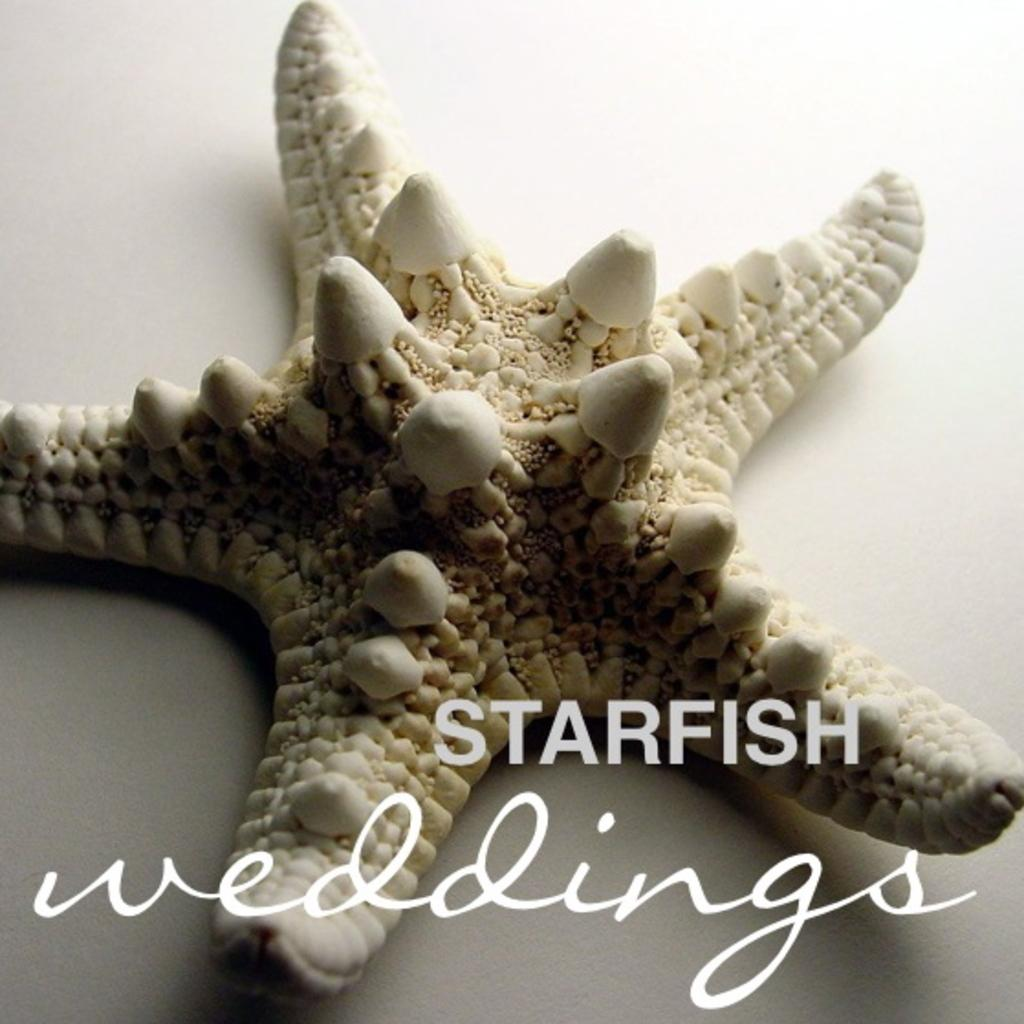What type of sea creature is in the image? There is a starfish in the image. What else can be seen at the bottom of the image? There is text at the bottom of the image. What type of prose is being written by the starfish in the image? There is no prose being written by the starfish in the image, as starfish do not have the ability to write. 